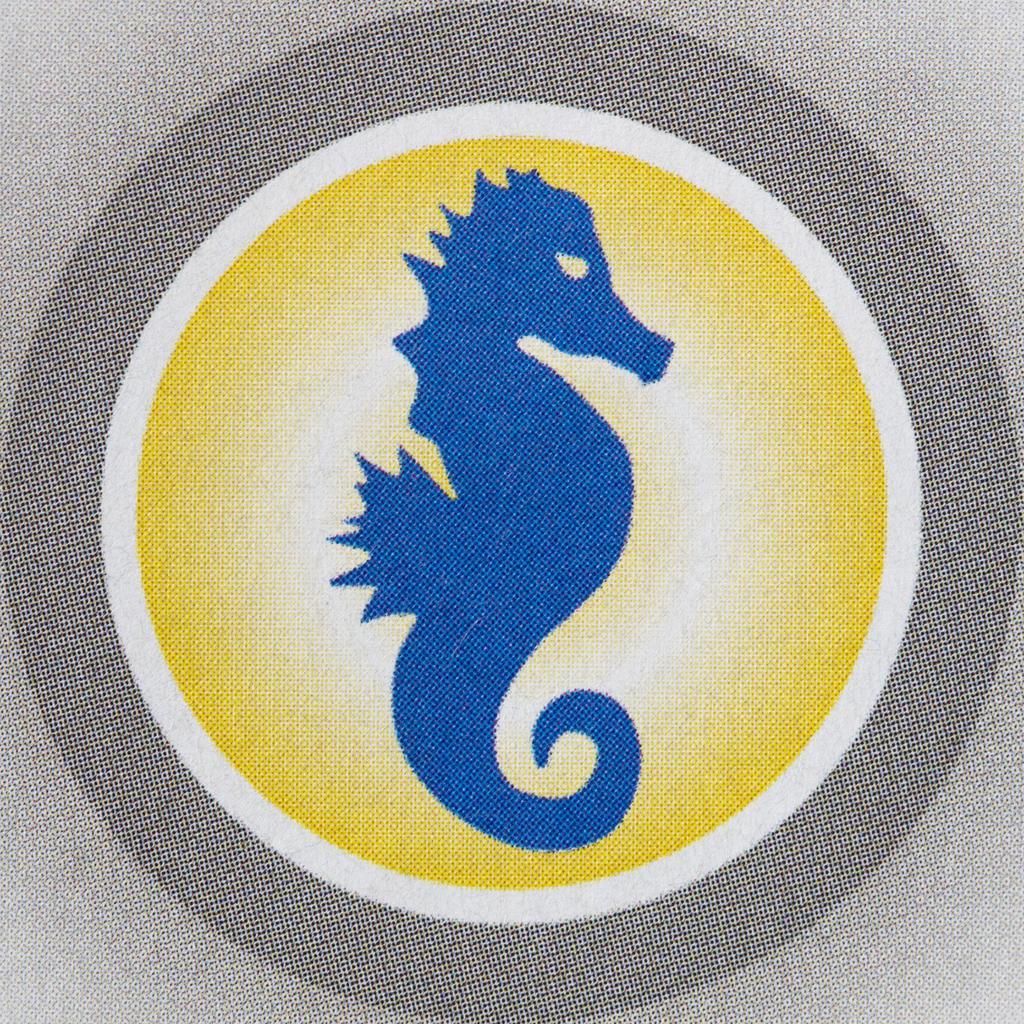Describe this image in one or two sentences. In this image I can see the cloth and there is an animal print on the cloth. I can see the cloth which is in blue, ash, white and yellow color. 